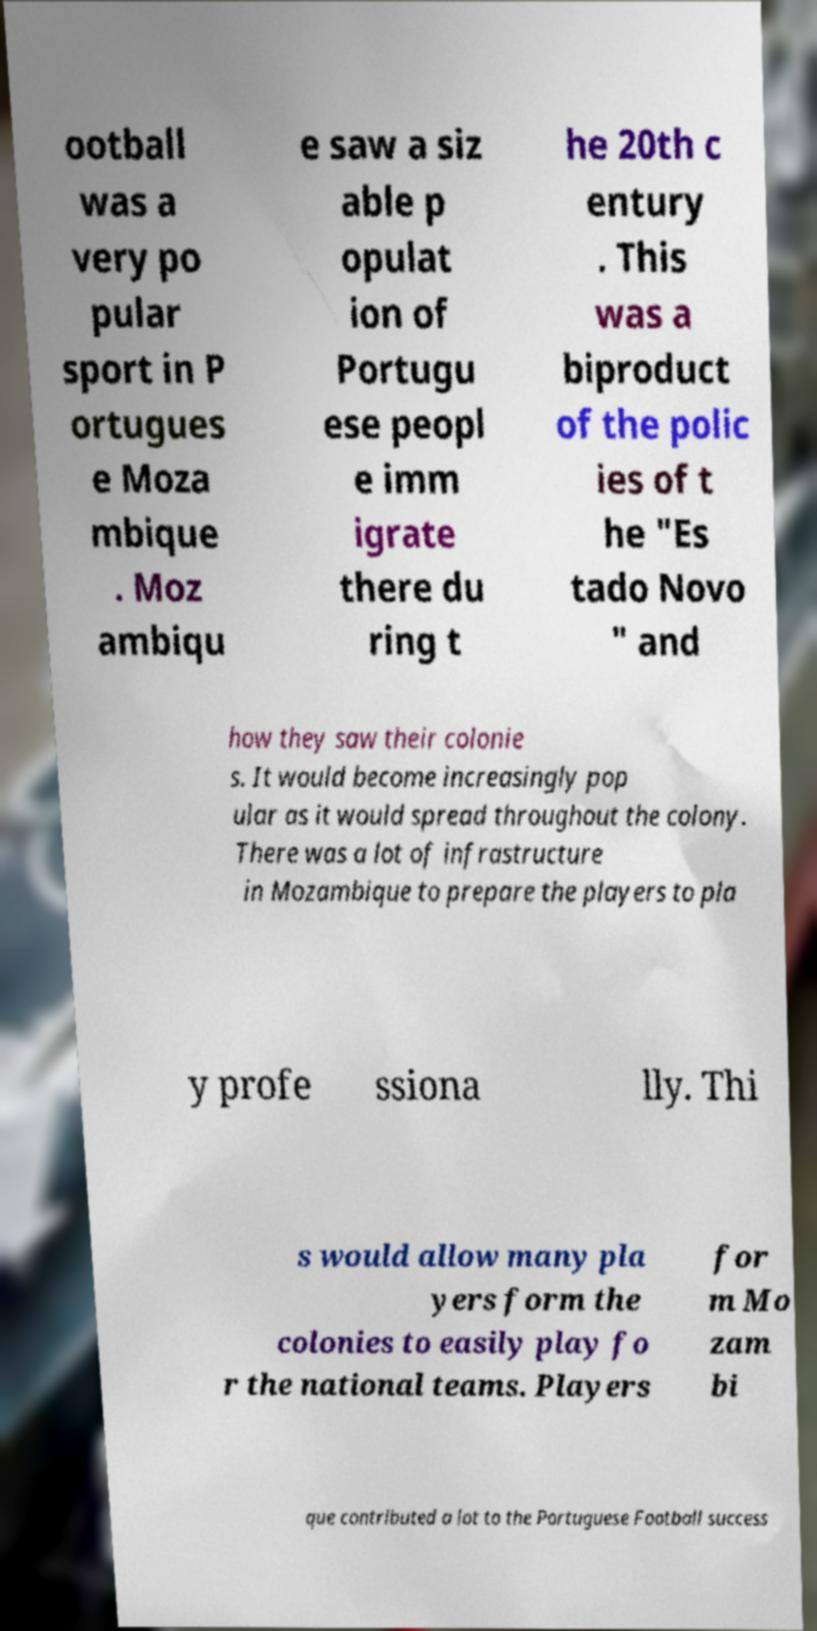Can you accurately transcribe the text from the provided image for me? ootball was a very po pular sport in P ortugues e Moza mbique . Moz ambiqu e saw a siz able p opulat ion of Portugu ese peopl e imm igrate there du ring t he 20th c entury . This was a biproduct of the polic ies of t he "Es tado Novo " and how they saw their colonie s. It would become increasingly pop ular as it would spread throughout the colony. There was a lot of infrastructure in Mozambique to prepare the players to pla y profe ssiona lly. Thi s would allow many pla yers form the colonies to easily play fo r the national teams. Players for m Mo zam bi que contributed a lot to the Portuguese Football success 